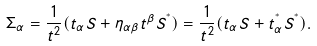Convert formula to latex. <formula><loc_0><loc_0><loc_500><loc_500>\Sigma _ { \alpha } = \frac { 1 } { t ^ { 2 } } ( t _ { \alpha } S + \eta _ { \alpha \beta } t ^ { \beta } S ^ { ^ { * } } ) = \frac { 1 } { t ^ { 2 } } ( t _ { \alpha } S + t _ { \alpha } ^ { ^ { * } } S ^ { ^ { * } } ) .</formula> 